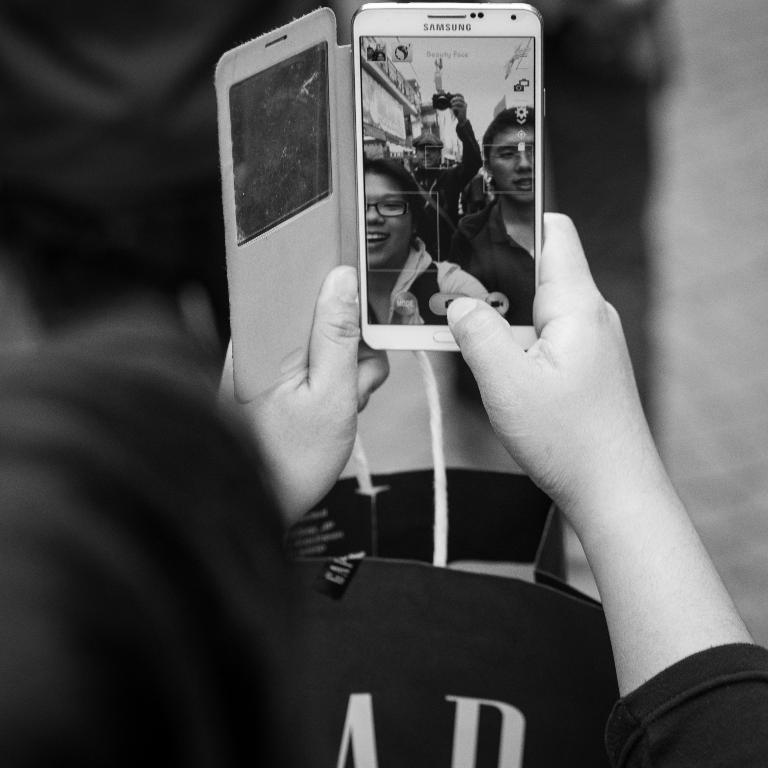<image>
Create a compact narrative representing the image presented. A Samsung phone is being used to take a picture. 